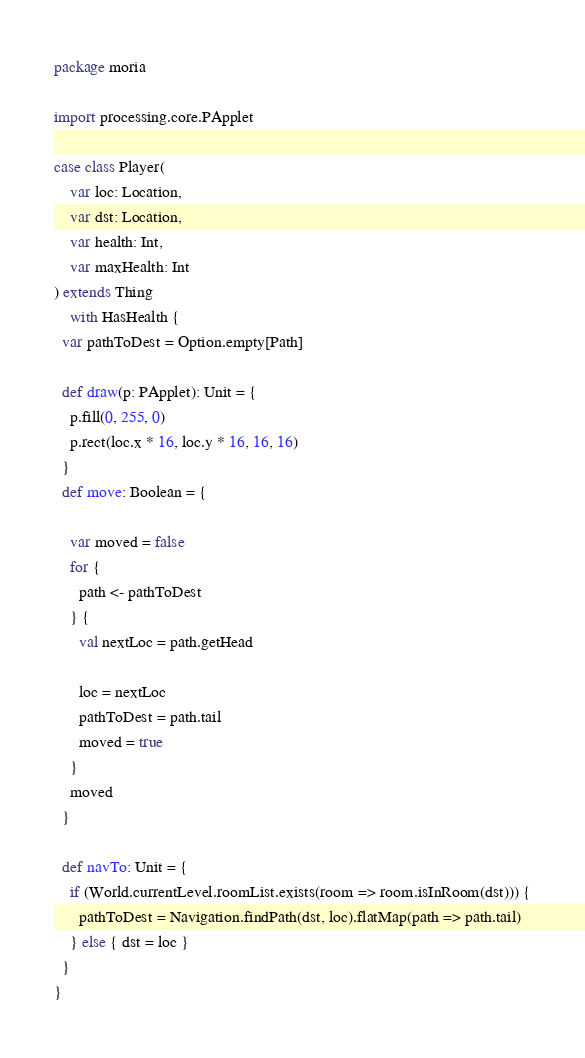Convert code to text. <code><loc_0><loc_0><loc_500><loc_500><_Scala_>package moria

import processing.core.PApplet

case class Player(
    var loc: Location,
    var dst: Location,
    var health: Int,
    var maxHealth: Int
) extends Thing
    with HasHealth {
  var pathToDest = Option.empty[Path]

  def draw(p: PApplet): Unit = {
    p.fill(0, 255, 0)
    p.rect(loc.x * 16, loc.y * 16, 16, 16)
  }
  def move: Boolean = {

    var moved = false
    for {
      path <- pathToDest
    } {
      val nextLoc = path.getHead

      loc = nextLoc
      pathToDest = path.tail
      moved = true
    }
    moved
  }

  def navTo: Unit = {
    if (World.currentLevel.roomList.exists(room => room.isInRoom(dst))) {
      pathToDest = Navigation.findPath(dst, loc).flatMap(path => path.tail)
    } else { dst = loc }
  }
}
</code> 